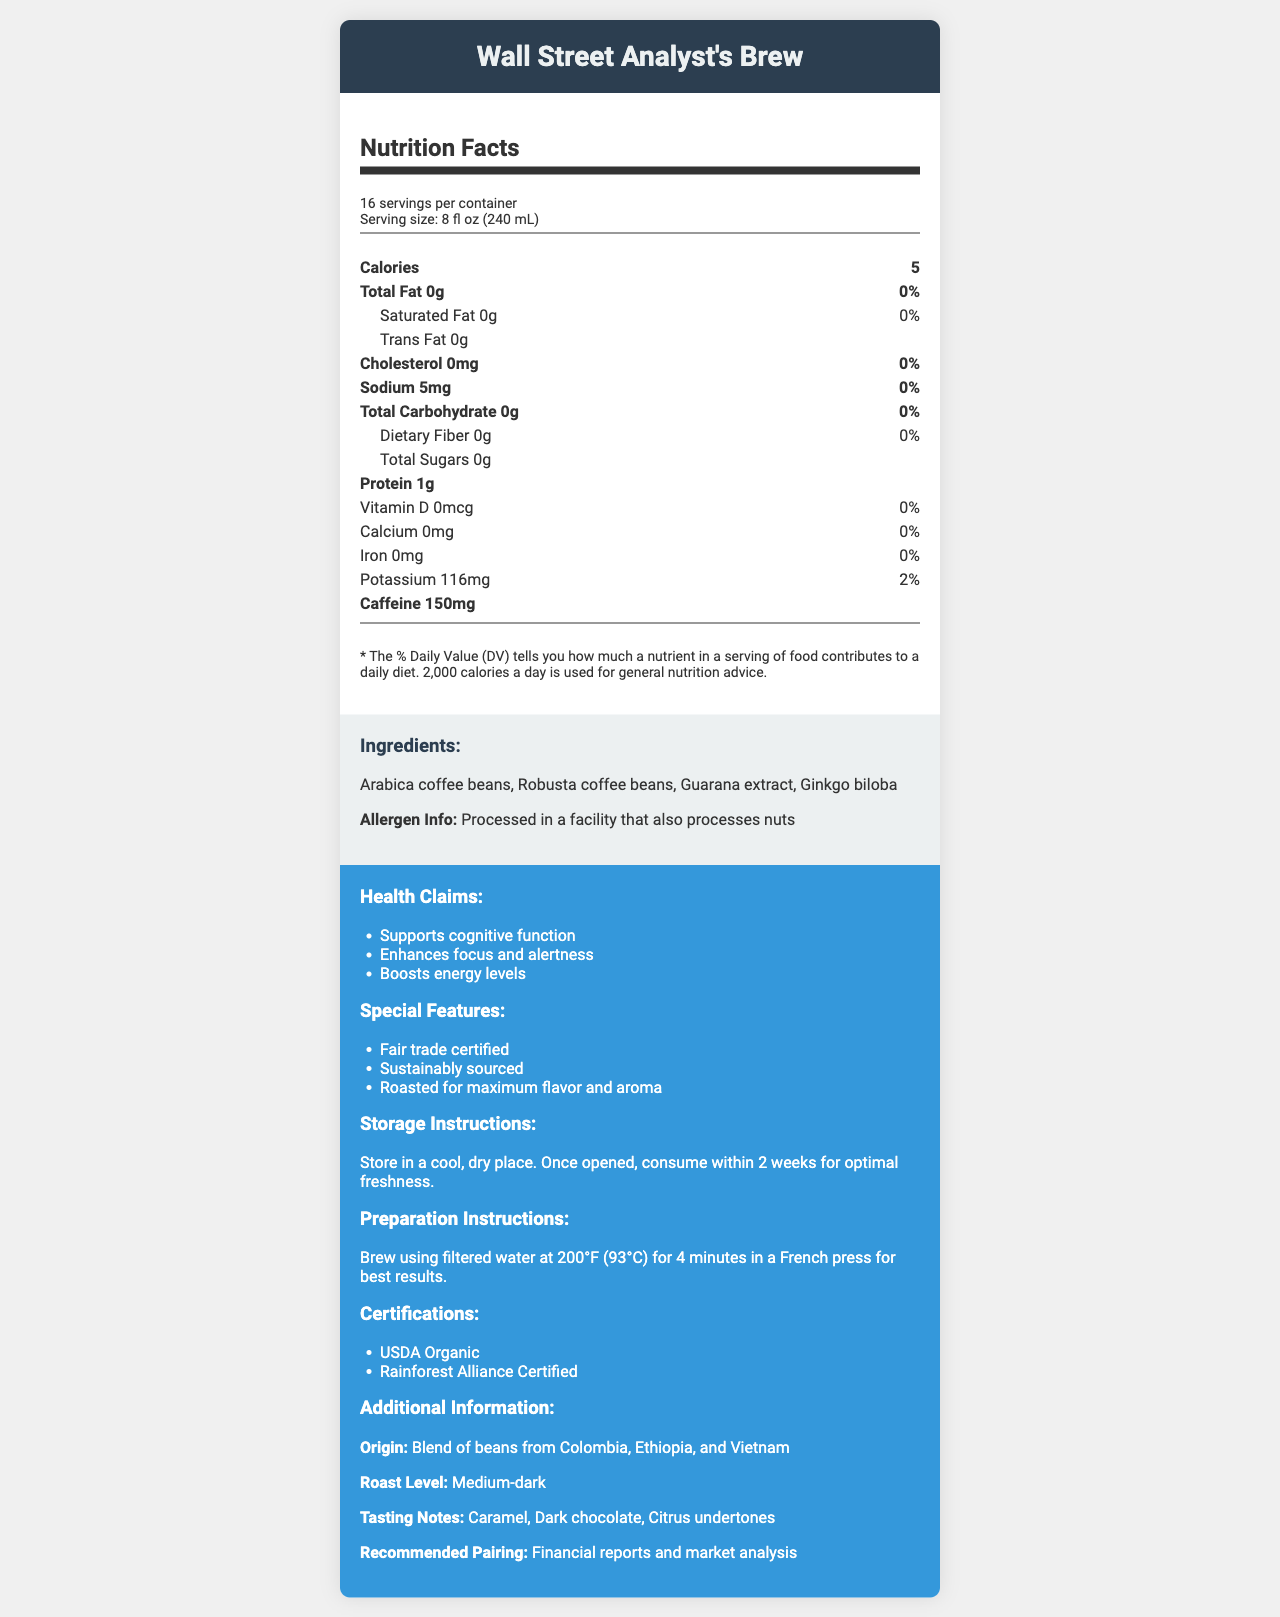what is the product name? The product name is listed at the top of the document under "Nutrition Facts".
Answer: Wall Street Analyst's Brew what is the serving size? The serving size is indicated in the first paragraph under "Nutrition Facts".
Answer: 8 fl oz (240 mL) how many servings are in one container? The number of servings per container is specified in the first paragraph under "Nutrition Facts".
Answer: 16 what is the total amount of caffeine per serving? The caffeine content is listed as 150 mg under "Nutrition Facts".
Answer: 150 mg what are the main health claims of this coffee blend? These health claims are listed under the "Health Claims" section.
Answer: Supports cognitive function, Enhances focus and alertness, Boosts energy levels which country is not part of the coffee bean blend's origin? A. Colombia B. Ethiopia C. Brazil D. Vietnam The document indicates that the beans originate from Colombia, Ethiopia, and Vietnam, but not from Brazil.
Answer: C. Brazil which of the following certifications does the product have? A. USDA Organic B. FSC Certified C. Non-GMO D. Rainforest Alliance Certified The coffee has both USDA Organic and Rainforest Alliance Certified certifications, as listed under "Certifications".
Answer: A. USDA Organic and D. Rainforest Alliance Certified is the product suitable for people with nut allergies? It is indicated under "allergen info" that the coffee is processed in a facility that also processes nuts.
Answer: No provide a summary of this product based on the document This summary covers the main features, health claims, nutritional content, certifications, and storage instructions detailed in the document.
Answer: The Wall Street Analyst's Brew is a gourmet coffee blend containing Arabica and Robusta beans with additional enhancements like Guarana and Ginkgo biloba. It has minimal calories and is high in caffeine, with health claims of supporting cognitive function, enhancing focus, and boosting energy. The product is sustainably sourced, fair trade certified, and carries USDA Organic and Rainforest Alliance certifications. It should be stored in a cool, dry place and consumed within two weeks after opening. what is the date this coffee blend was introduced to the market? The document does not provide any information regarding the market introduction date of the coffee blend.
Answer: Cannot be determined what is the recommended water temperature for brewing this coffee? The preparation instructions state that filtered water at 200°F (93°C) should be used for brewing.
Answer: 200°F (93°C) what is the roast level of this coffee blend? The roast level is listed as "Medium-dark" under "Additional Information".
Answer: Medium-dark 